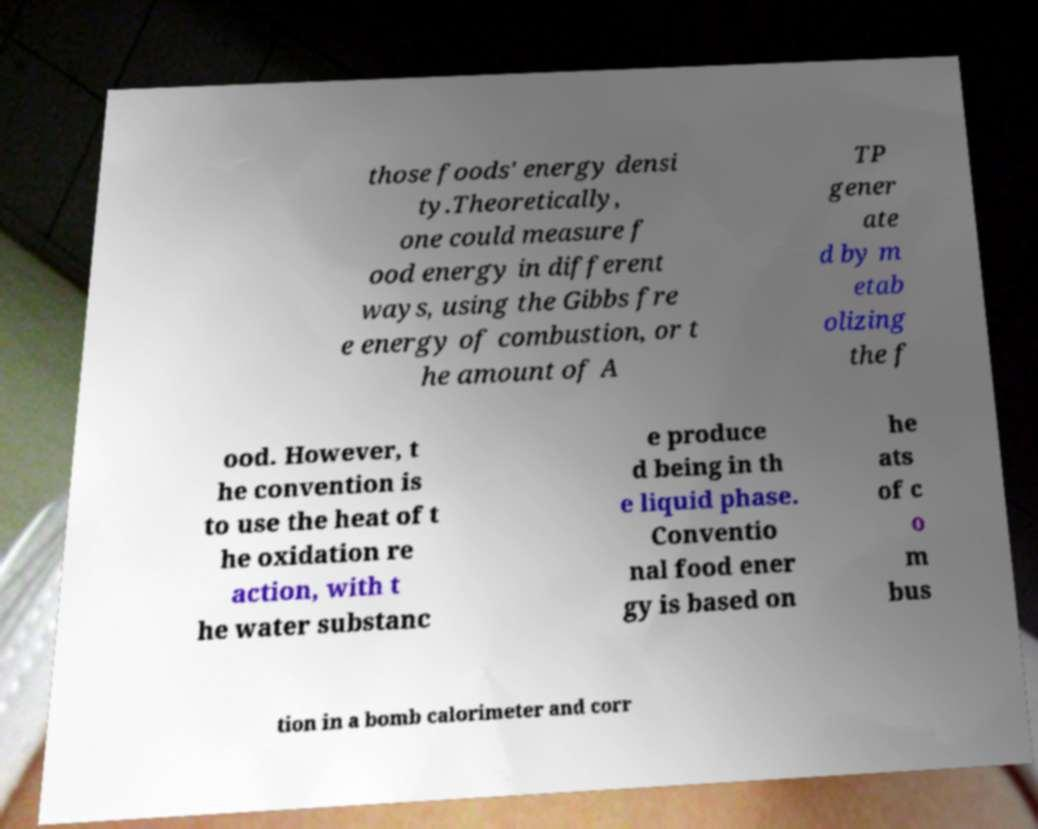Please read and relay the text visible in this image. What does it say? those foods' energy densi ty.Theoretically, one could measure f ood energy in different ways, using the Gibbs fre e energy of combustion, or t he amount of A TP gener ate d by m etab olizing the f ood. However, t he convention is to use the heat of t he oxidation re action, with t he water substanc e produce d being in th e liquid phase. Conventio nal food ener gy is based on he ats of c o m bus tion in a bomb calorimeter and corr 